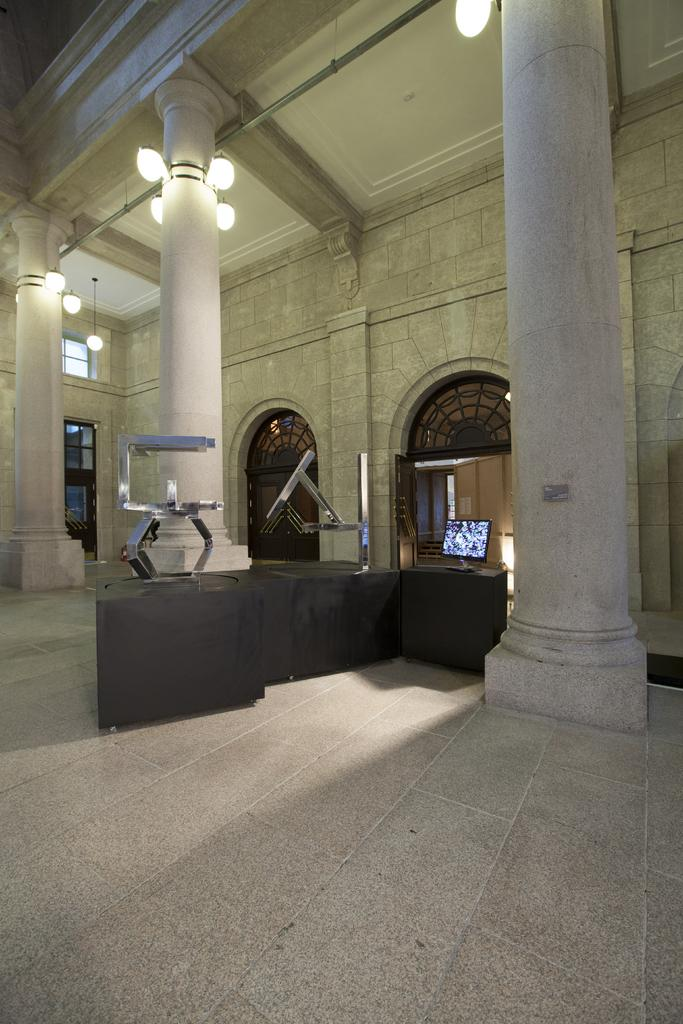What structures are located in the middle of the image? There are three pillars in the middle of the image. What piece of furniture is present in the image? There is a desk in the image. What is placed on the desk? A monitor is placed on the desk. What can be seen in the background of the image? There is a wall in the background of the image. What arithmetic problem is being solved on the monitor in the image? There is no arithmetic problem visible on the monitor in the image. Can you describe the scene taking place in the image? The image does not depict a scene; it shows a desk with a monitor and three pillars in the middle of the image. Is there a kitten visible in the image? No, there is no kitten present in the image. 